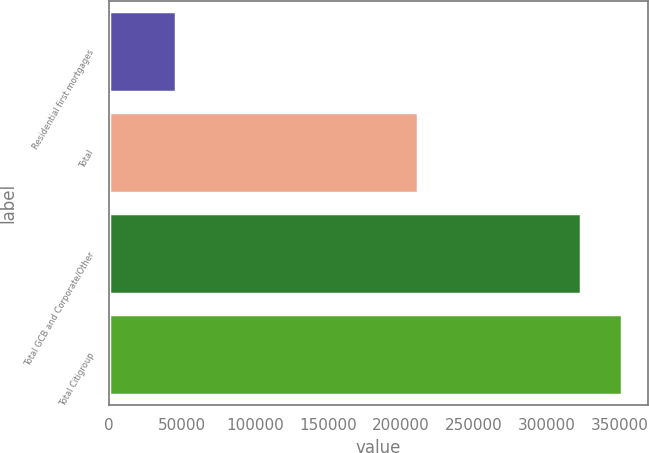Convert chart to OTSL. <chart><loc_0><loc_0><loc_500><loc_500><bar_chart><fcel>Residential first mortgages<fcel>Total<fcel>Total GCB and Corporate/Other<fcel>Total Citigroup<nl><fcel>45953<fcel>211250<fcel>323435<fcel>351183<nl></chart> 